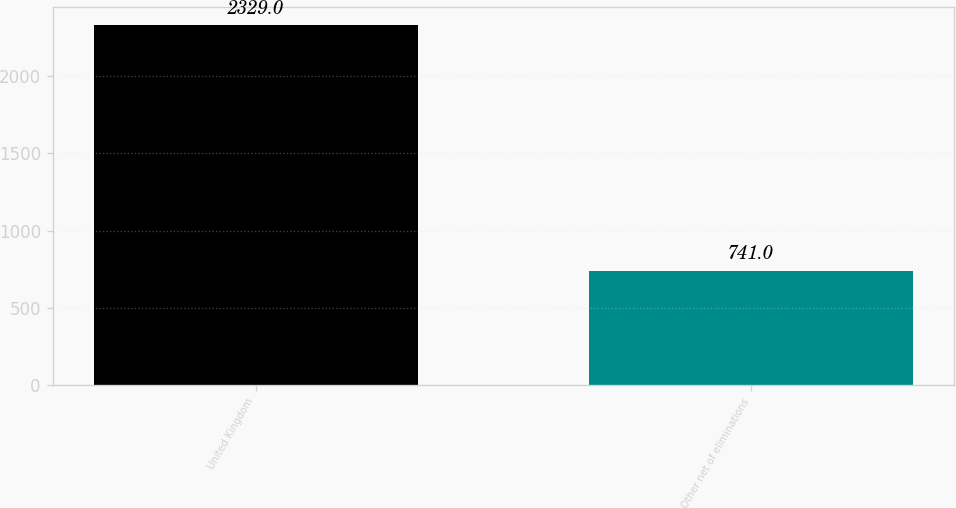Convert chart. <chart><loc_0><loc_0><loc_500><loc_500><bar_chart><fcel>United Kingdom<fcel>Other net of eliminations<nl><fcel>2329<fcel>741<nl></chart> 